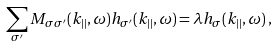Convert formula to latex. <formula><loc_0><loc_0><loc_500><loc_500>\sum _ { \sigma ^ { \prime } } M _ { \sigma \sigma ^ { \prime } } ( { k } _ { | | } , \omega ) h _ { \sigma ^ { \prime } } ( { k } _ { | | } , \omega ) = \lambda h _ { \sigma } ( { k } _ { | | } , \omega ) \, ,</formula> 